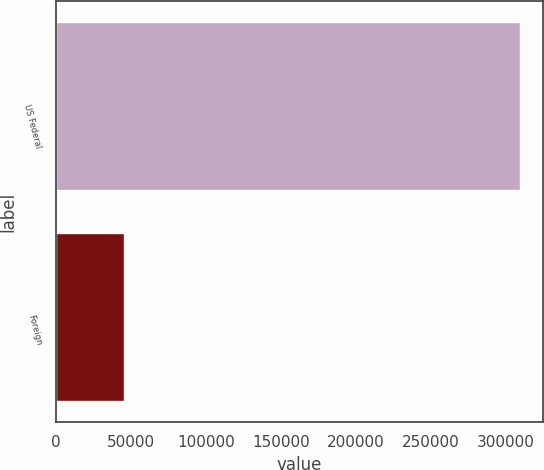<chart> <loc_0><loc_0><loc_500><loc_500><bar_chart><fcel>US Federal<fcel>Foreign<nl><fcel>309262<fcel>45362<nl></chart> 